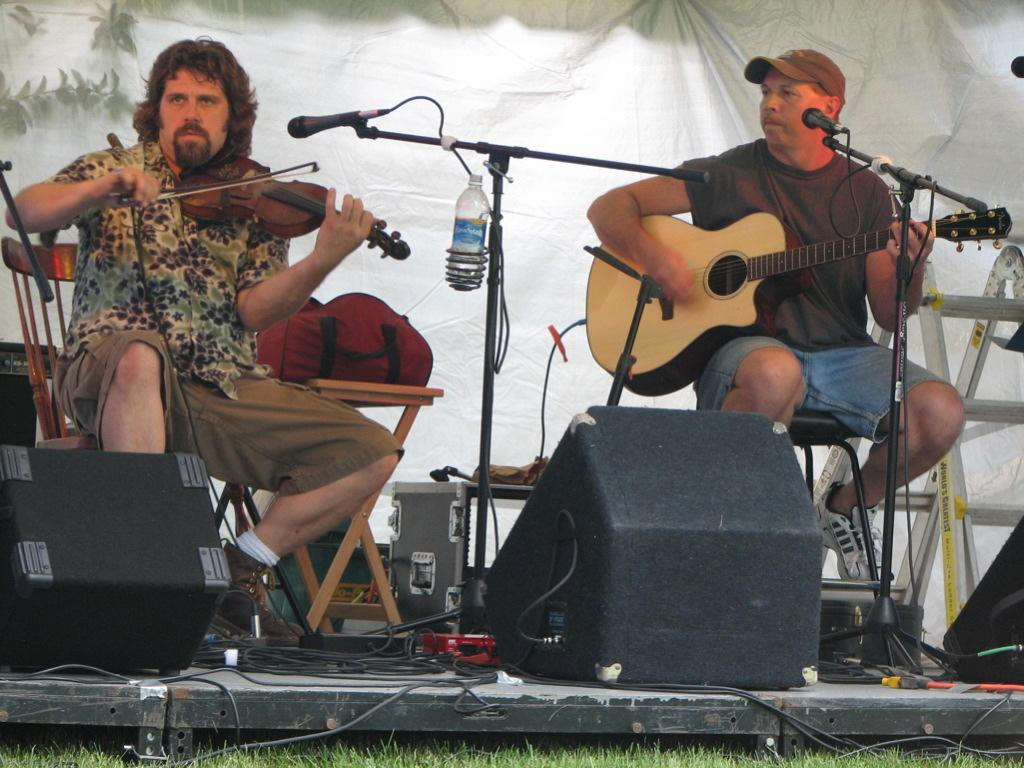How many people are in the image? There are two persons in the image. What are the two persons doing? The two persons are playing guitar. What object is used for amplifying sound in the image? There is a microphone (mike) in the image. What additional object can be seen in the image? There is a bottle in the image. What type of objects are present in the image related to music? There are musical instruments in the image. What can be seen in the background of the image? There is a cloth visible in the background of the image. What type of flowers can be seen growing near the guitar in the image? There are no flowers present in the image; it features two persons playing guitar, a microphone, a bottle, musical instruments, and a cloth in the background. 